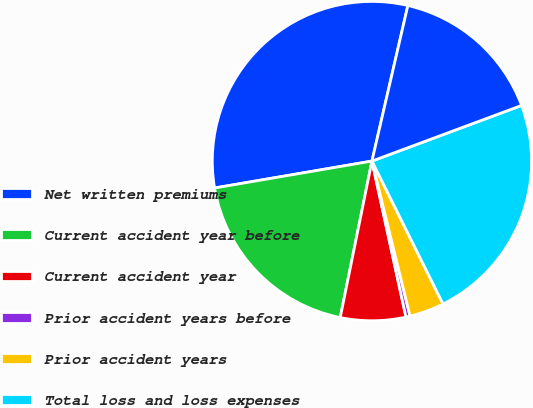Convert chart. <chart><loc_0><loc_0><loc_500><loc_500><pie_chart><fcel>Net written premiums<fcel>Current accident year before<fcel>Current accident year<fcel>Prior accident years before<fcel>Prior accident years<fcel>Total loss and loss expenses<fcel>Total loss and loss expense<nl><fcel>31.31%<fcel>19.12%<fcel>6.6%<fcel>0.42%<fcel>3.51%<fcel>23.32%<fcel>15.72%<nl></chart> 